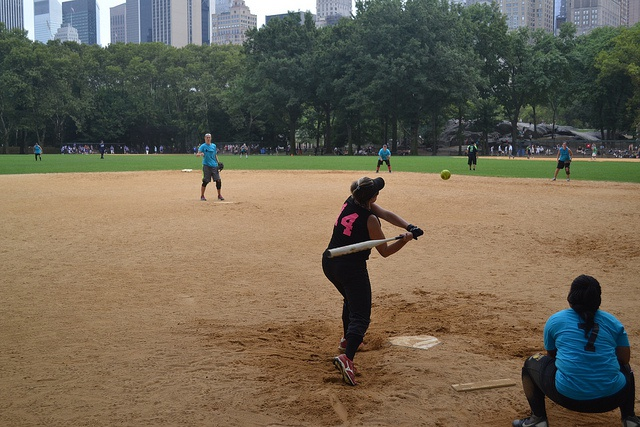Describe the objects in this image and their specific colors. I can see people in darkgray, black, darkblue, blue, and teal tones, people in darkgray, black, maroon, tan, and gray tones, people in darkgray, black, gray, and green tones, people in darkgray, black, teal, blue, and gray tones, and baseball bat in darkgray, gray, black, and maroon tones in this image. 